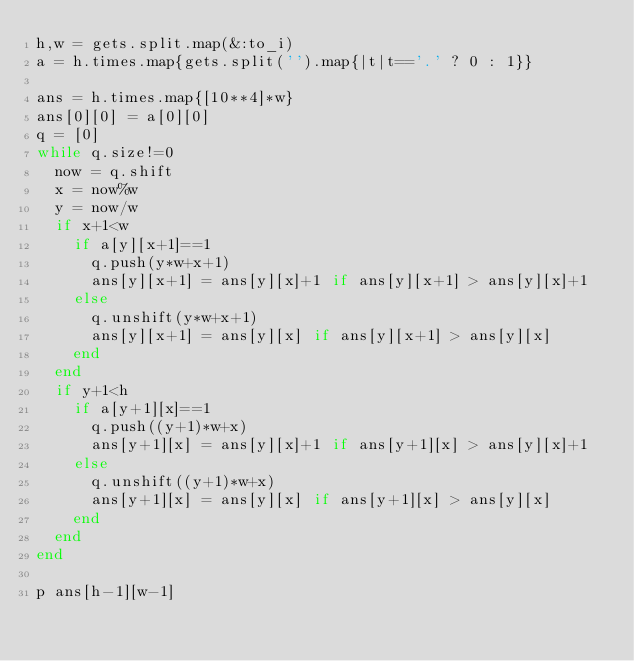<code> <loc_0><loc_0><loc_500><loc_500><_Ruby_>h,w = gets.split.map(&:to_i)
a = h.times.map{gets.split('').map{|t|t=='.' ? 0 : 1}}

ans = h.times.map{[10**4]*w}
ans[0][0] = a[0][0]
q = [0]
while q.size!=0
  now = q.shift
  x = now%w
  y = now/w
  if x+1<w
    if a[y][x+1]==1
      q.push(y*w+x+1)
      ans[y][x+1] = ans[y][x]+1 if ans[y][x+1] > ans[y][x]+1
    else
      q.unshift(y*w+x+1)
      ans[y][x+1] = ans[y][x] if ans[y][x+1] > ans[y][x]
    end
  end
  if y+1<h
    if a[y+1][x]==1
      q.push((y+1)*w+x)
      ans[y+1][x] = ans[y][x]+1 if ans[y+1][x] > ans[y][x]+1
    else
      q.unshift((y+1)*w+x)
      ans[y+1][x] = ans[y][x] if ans[y+1][x] > ans[y][x]
    end
  end
end

p ans[h-1][w-1]
</code> 